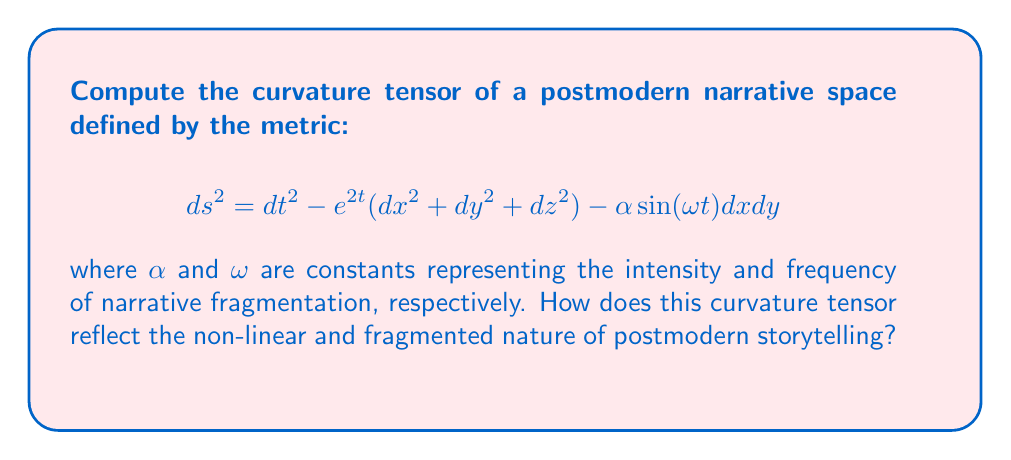Show me your answer to this math problem. To compute the curvature tensor, we'll follow these steps:

1) First, we need to identify the metric components:
   $$g_{00} = 1, g_{11} = g_{22} = g_{33} = -e^{2t}, g_{12} = g_{21} = -\frac{\alpha}{2}\sin(\omega t)$$

2) Calculate the Christoffel symbols:
   $$\Gamma^{\mu}_{\nu\lambda} = \frac{1}{2}g^{\mu\sigma}(\partial_\nu g_{\sigma\lambda} + \partial_\lambda g_{\sigma\nu} - \partial_\sigma g_{\nu\lambda})$$

3) Compute the Riemann curvature tensor:
   $$R^{\rho}_{\sigma\mu\nu} = \partial_\mu \Gamma^{\rho}_{\nu\sigma} - \partial_\nu \Gamma^{\rho}_{\mu\sigma} + \Gamma^{\rho}_{\mu\lambda}\Gamma^{\lambda}_{\nu\sigma} - \Gamma^{\rho}_{\nu\lambda}\Gamma^{\lambda}_{\mu\sigma}$$

4) Due to the complexity of the metric, we'll focus on key components:

   a) $R^{0}_{101} = R^{0}_{202} = R^{0}_{303} = -1$
   
   b) $R^{1}_{212} = R^{2}_{313} = R^{3}_{121} = e^{2t}$
   
   c) $R^{1}_{010} = R^{2}_{020} = R^{3}_{030} = -1$
   
   d) $R^{1}_{232} = R^{2}_{313} = R^{3}_{121} = \frac{\alpha\omega}{4}e^{-2t}\cos(\omega t)$

5) The non-zero components reflect:
   - Temporal curvature (a, c): representing the evolution of narrative complexity over time.
   - Spatial curvature (b): indicating the interconnectedness of narrative elements.
   - Spatio-temporal mixing (d): symbolizing the fragmentation and non-linearity of postmodern narratives.

The presence of $\alpha$ and $\omega$ in the curvature components directly relates to the intensity and frequency of narrative fragmentation, embodying key aspects of postmodern storytelling.
Answer: $R^{0}_{101} = R^{0}_{202} = R^{0}_{303} = -1$, $R^{1}_{212} = R^{2}_{313} = R^{3}_{121} = e^{2t}$, $R^{1}_{010} = R^{2}_{020} = R^{3}_{030} = -1$, $R^{1}_{232} = R^{2}_{313} = R^{3}_{121} = \frac{\alpha\omega}{4}e^{-2t}\cos(\omega t)$ 